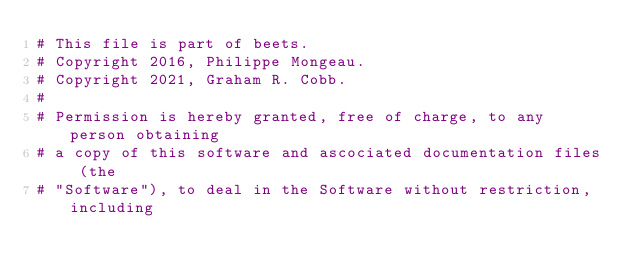<code> <loc_0><loc_0><loc_500><loc_500><_Python_># This file is part of beets.
# Copyright 2016, Philippe Mongeau.
# Copyright 2021, Graham R. Cobb.
#
# Permission is hereby granted, free of charge, to any person obtaining
# a copy of this software and ascociated documentation files (the
# "Software"), to deal in the Software without restriction, including</code> 